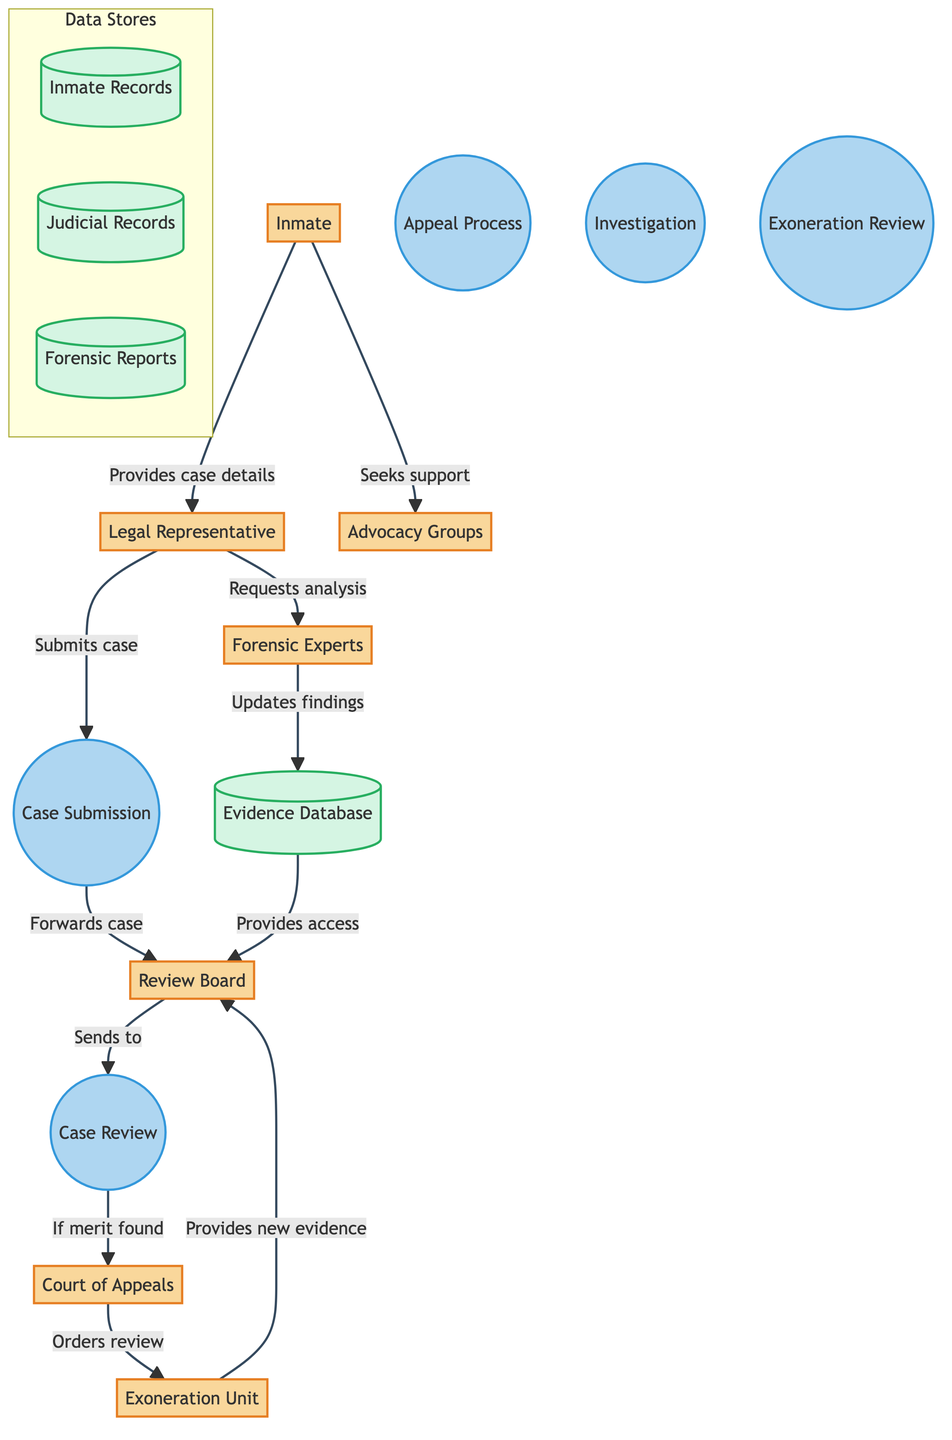What is the initial step in the wrongful conviction review process? The initial step is labeled as "Case Submission," where the Legal Representative submits the case for review on behalf of the Inmate.
Answer: Case Submission How many main entities are present in the diagram? By counting the distinct entities depicted: Inmate, Legal Representative, Review Board, Court of Appeals, Exoneration Unit, Advocacy Groups, Forensic Experts, and Evidence Database, there are a total of eight entities.
Answer: Eight Who receives the case after the Review Board examines it? The Review Board forwards the case to the Court of Appeals if merit is found during their review, as indicated by the arrow connecting these two entities.
Answer: Court of Appeals What action does the Inmate take towards Advocacy Groups? The diagram shows that the Inmate seeks support from Advocacy Groups, represented by the directed arrow from Inmate to Advocacy Groups.
Answer: Seeks support What happens if new evidence is found by the Exoneration Unit? The Exoneration Unit provides new evidence to the Review Board for further action, as depicted by the directed flow from Exoneration Unit to Review Board, indicating their interaction.
Answer: Provides new evidence How does the Legal Representative complement the forensic investigation? The Legal Representative requests analysis from Forensic Experts, based on the flow from the Legal Representative to Forensic Experts, which indicates their collaboration in the investigation process.
Answer: Requests analysis What type of database is mentioned for housing evidence? The diagram makes reference to an "Evidence Database," which is a storage entity for both physical and digital evidence pertinent to the cases under review.
Answer: Evidence Database What is the purpose of the Court of Appeals in the process? The Court of Appeals functions to conduct a judicial review of the case based on the findings from the Review Board, which is indicated by the flow from Review Board to Court of Appeals.
Answer: Judicial review What does the Review Board do with the evidence from the Evidence Database? The Review Board accesses new and old evidence from the Evidence Database, as shown in the flow leading from Evidence Database to Review Board, illustrating their dependency on this resource.
Answer: Provides access 